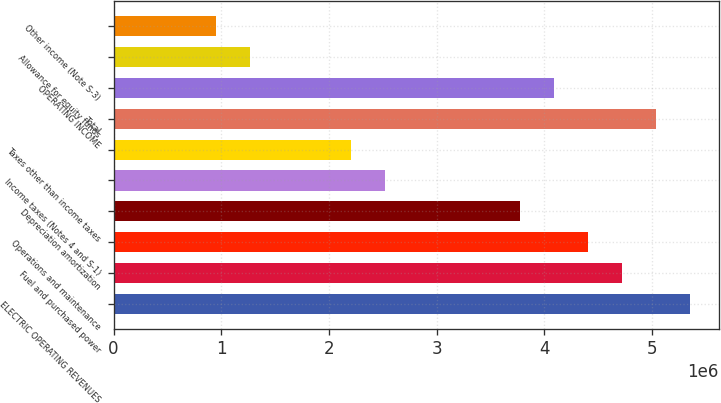Convert chart. <chart><loc_0><loc_0><loc_500><loc_500><bar_chart><fcel>ELECTRIC OPERATING REVENUES<fcel>Fuel and purchased power<fcel>Operations and maintenance<fcel>Depreciation amortization<fcel>Income taxes (Notes 4 and S-1)<fcel>Taxes other than income taxes<fcel>Total<fcel>OPERATING INCOME<fcel>Allowance for equity funds<fcel>Other income (Note S-3)<nl><fcel>5.35088e+06<fcel>4.72191e+06<fcel>4.40743e+06<fcel>3.77846e+06<fcel>2.52054e+06<fcel>2.20605e+06<fcel>5.0364e+06<fcel>4.09295e+06<fcel>1.2626e+06<fcel>948122<nl></chart> 